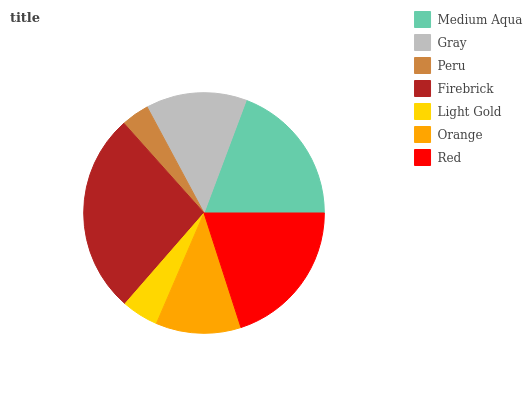Is Peru the minimum?
Answer yes or no. Yes. Is Firebrick the maximum?
Answer yes or no. Yes. Is Gray the minimum?
Answer yes or no. No. Is Gray the maximum?
Answer yes or no. No. Is Medium Aqua greater than Gray?
Answer yes or no. Yes. Is Gray less than Medium Aqua?
Answer yes or no. Yes. Is Gray greater than Medium Aqua?
Answer yes or no. No. Is Medium Aqua less than Gray?
Answer yes or no. No. Is Gray the high median?
Answer yes or no. Yes. Is Gray the low median?
Answer yes or no. Yes. Is Peru the high median?
Answer yes or no. No. Is Orange the low median?
Answer yes or no. No. 